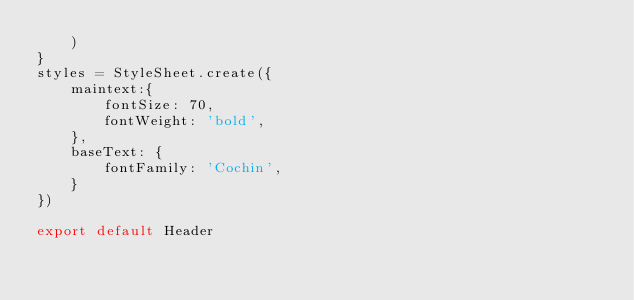Convert code to text. <code><loc_0><loc_0><loc_500><loc_500><_JavaScript_>    )
}
styles = StyleSheet.create({
    maintext:{
        fontSize: 70,
        fontWeight: 'bold',
    },
    baseText: {
        fontFamily: 'Cochin',
    }
})

export default Header
</code> 